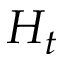<formula> <loc_0><loc_0><loc_500><loc_500>H _ { t }</formula> 